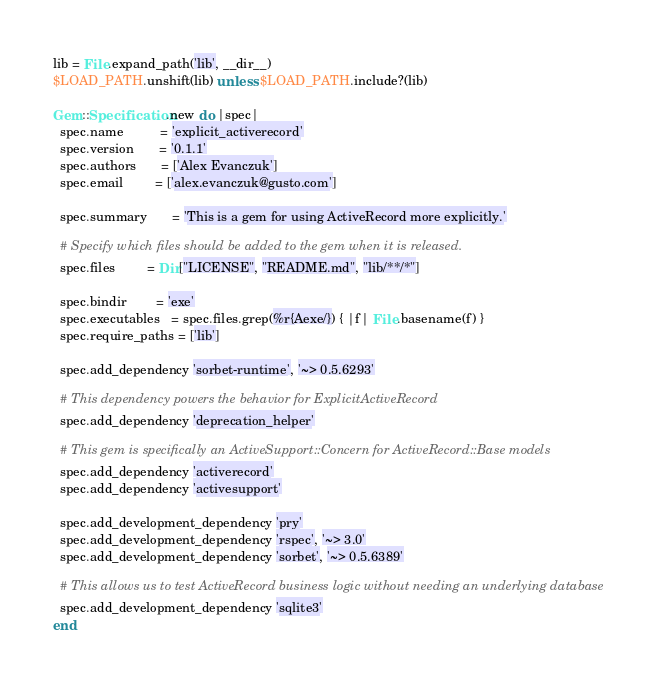<code> <loc_0><loc_0><loc_500><loc_500><_Ruby_>lib = File.expand_path('lib', __dir__)
$LOAD_PATH.unshift(lib) unless $LOAD_PATH.include?(lib)

Gem::Specification.new do |spec|
  spec.name          = 'explicit_activerecord'
  spec.version       = '0.1.1'
  spec.authors       = ['Alex Evanczuk']
  spec.email         = ['alex.evanczuk@gusto.com']

  spec.summary       = 'This is a gem for using ActiveRecord more explicitly.'

  # Specify which files should be added to the gem when it is released.
  spec.files         = Dir["LICENSE", "README.md", "lib/**/*"]

  spec.bindir        = 'exe'
  spec.executables   = spec.files.grep(%r{Aexe/}) { |f| File.basename(f) }
  spec.require_paths = ['lib']

  spec.add_dependency 'sorbet-runtime', '~> 0.5.6293'

  # This dependency powers the behavior for ExplicitActiveRecord
  spec.add_dependency 'deprecation_helper'

  # This gem is specifically an ActiveSupport::Concern for ActiveRecord::Base models
  spec.add_dependency 'activerecord'
  spec.add_dependency 'activesupport'

  spec.add_development_dependency 'pry'
  spec.add_development_dependency 'rspec', '~> 3.0'
  spec.add_development_dependency 'sorbet', '~> 0.5.6389'

  # This allows us to test ActiveRecord business logic without needing an underlying database
  spec.add_development_dependency 'sqlite3'
end
</code> 